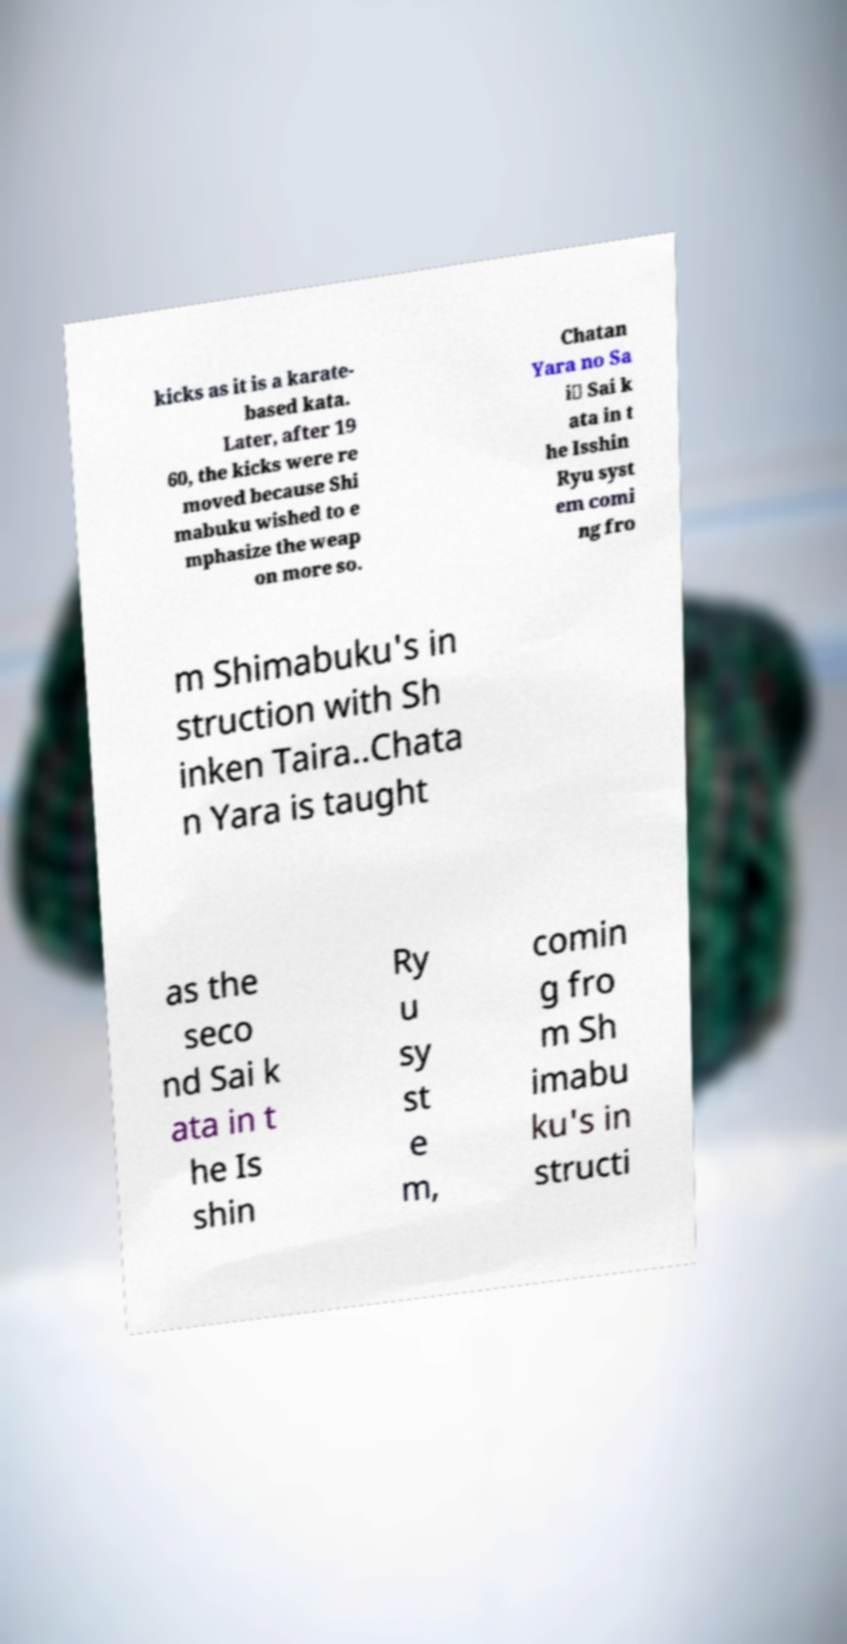There's text embedded in this image that I need extracted. Can you transcribe it verbatim? kicks as it is a karate- based kata. Later, after 19 60, the kicks were re moved because Shi mabuku wished to e mphasize the weap on more so. Chatan Yara no Sa i\ Sai k ata in t he Isshin Ryu syst em comi ng fro m Shimabuku's in struction with Sh inken Taira..Chata n Yara is taught as the seco nd Sai k ata in t he Is shin Ry u sy st e m, comin g fro m Sh imabu ku's in structi 